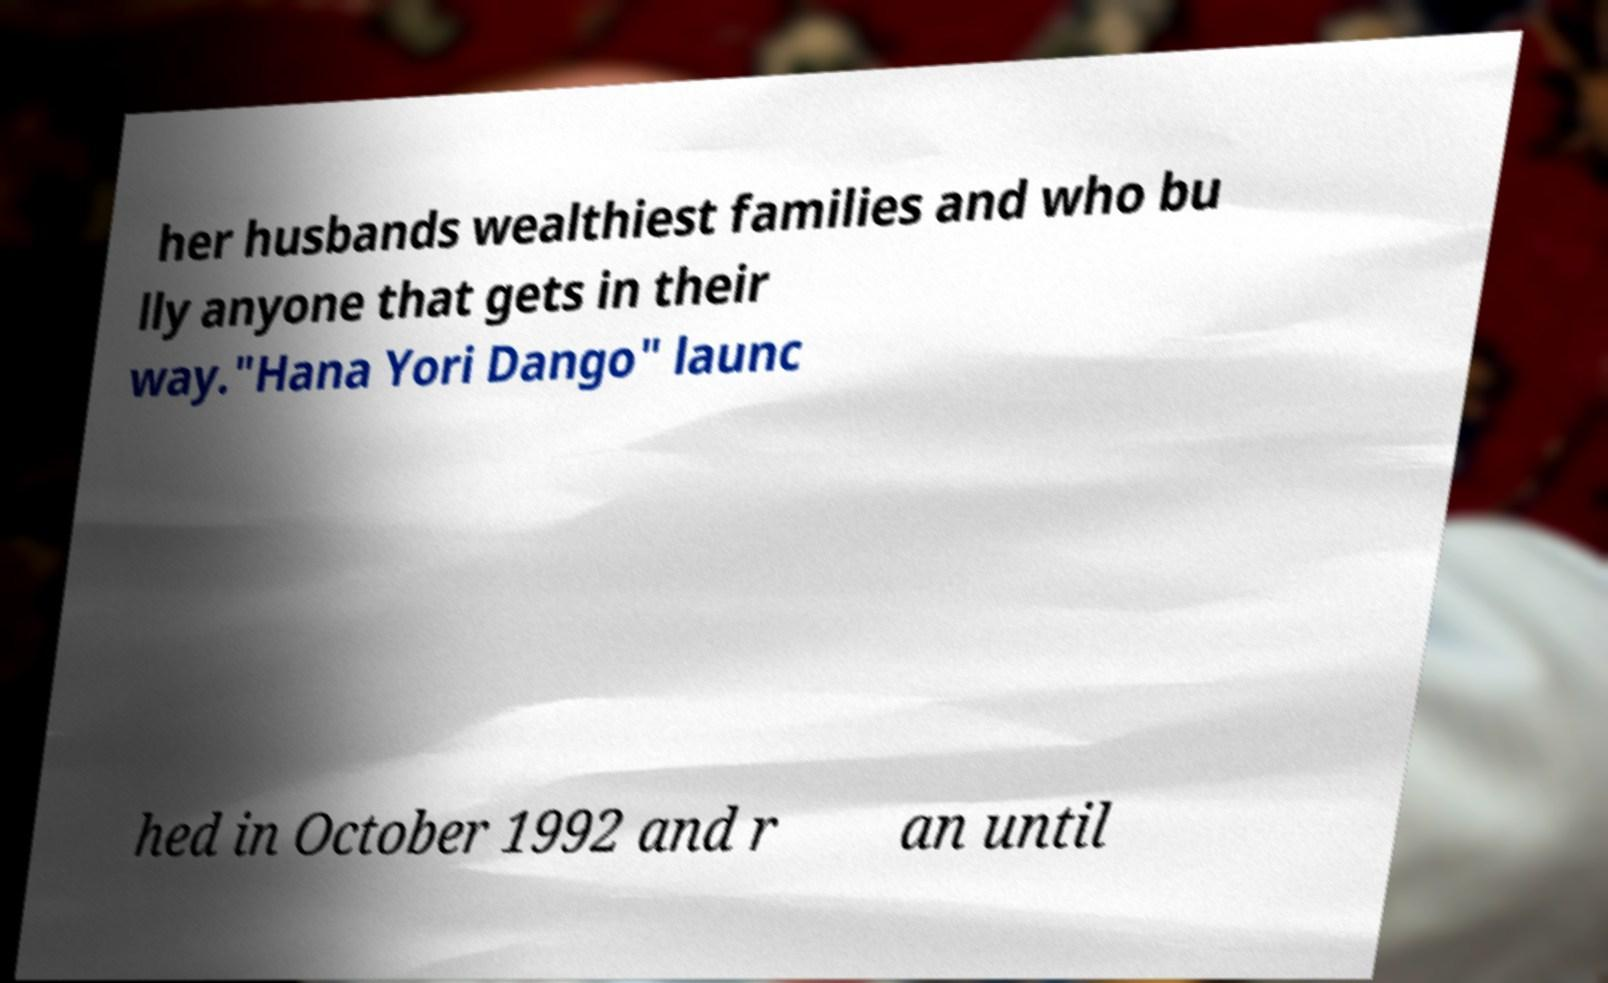Can you read and provide the text displayed in the image?This photo seems to have some interesting text. Can you extract and type it out for me? her husbands wealthiest families and who bu lly anyone that gets in their way."Hana Yori Dango" launc hed in October 1992 and r an until 